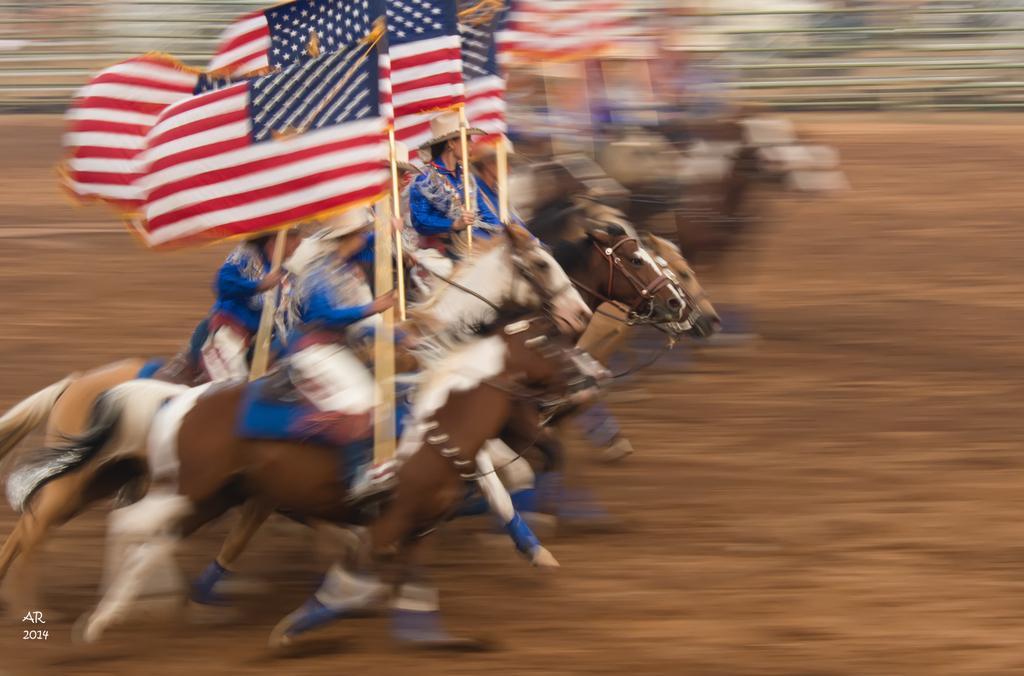Can you describe this image briefly? In this image there are some people sitting on horses and riding and they are holding poles and flags, and there is a blurry background. 